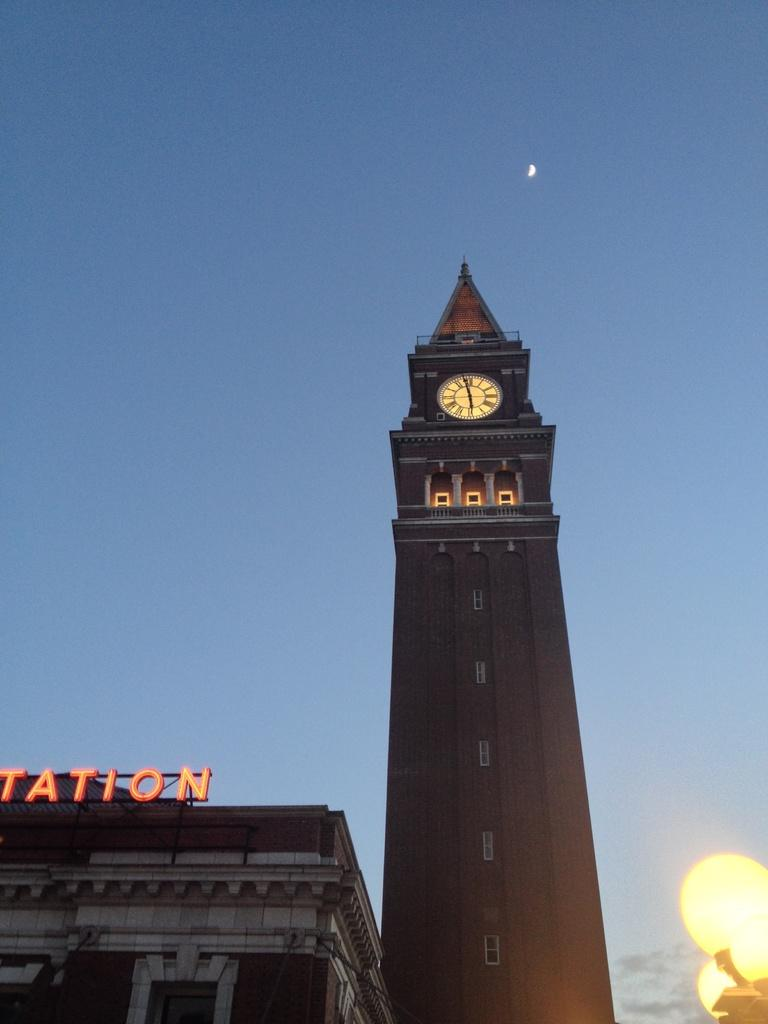What type of structures are present in the image? The image contains buildings. Can you describe any specific features of the buildings? There is a clock on one of the buildings. What can be seen in the sky in the image? The sky is visible at the top of the image. Where is the light source located in the image? There is light in the bottom right corner of the image. What type of kitten can be seen in the image? There is no kitten present in the image. Does the existence of the buildings in the image prove the existence of a parallel universe? The existence of the buildings in the image does not prove the existence of a parallel universe; it simply shows a scene with buildings, a clock, and a sky. 